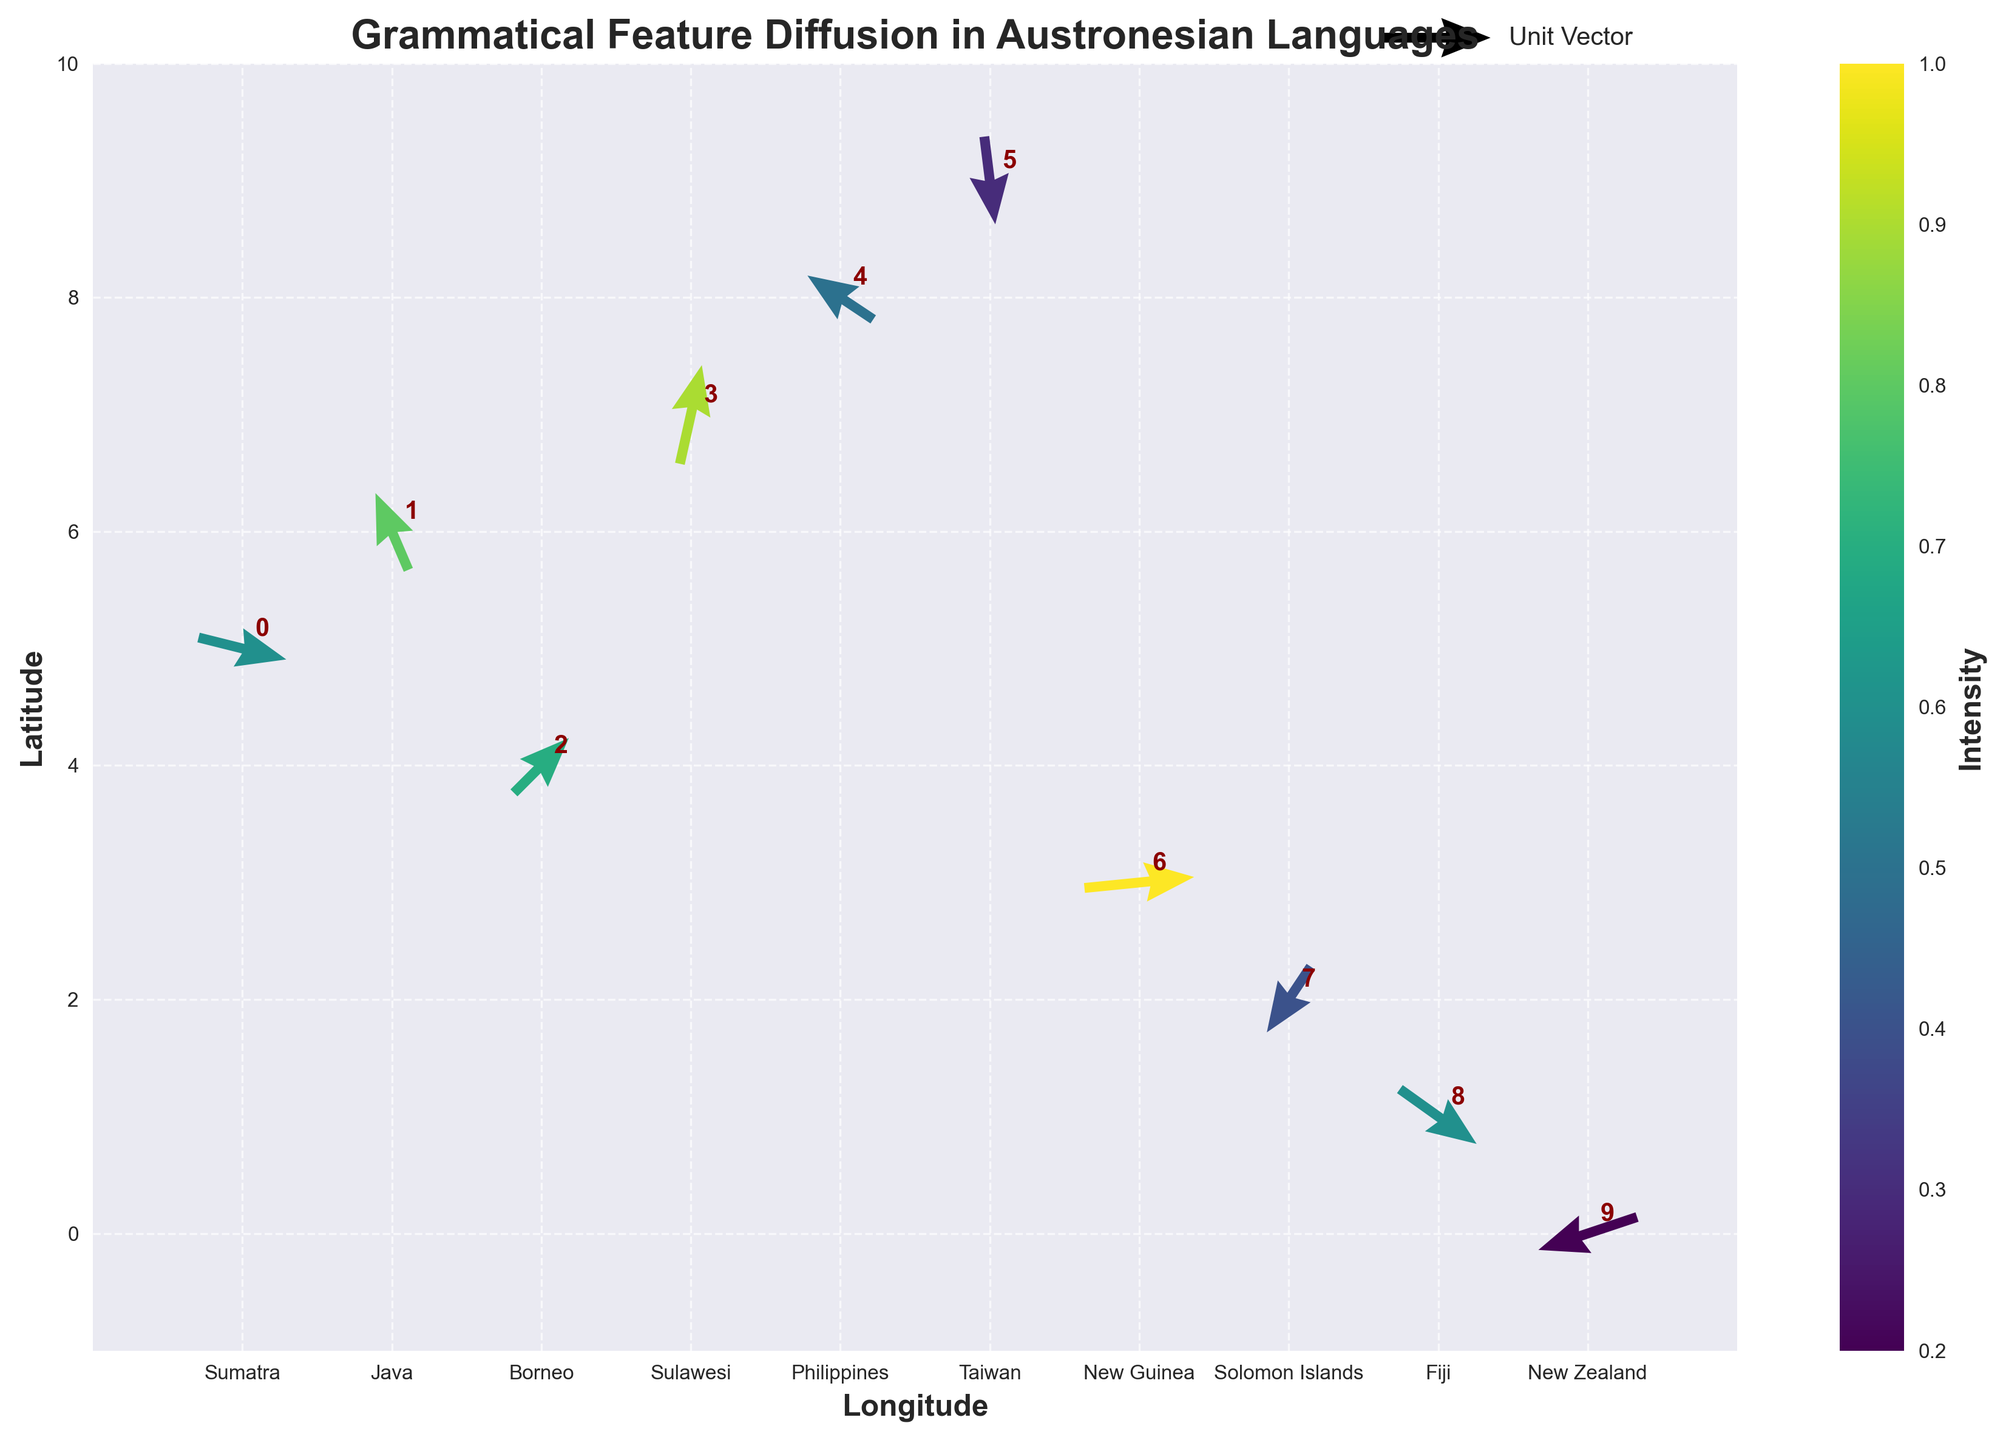What's the title of the plot? The title of the plot is often found at the top of the figure, clearly indicating the subject of the visualization. Here, the title "Grammatical Feature Diffusion in Austronesian Languages" is displayed at the top center.
Answer: Grammatical Feature Diffusion in Austronesian Languages Which islands have the highest and lowest intensities of grammatical feature diffusion? To find the highest and lowest intensities, look at the color bar and the arrows' colors. The highest intensity (brightest color) corresponds to New Guinea (intensity = 1.0), and the lowest intensity (dullest color) corresponds to New Zealand (intensity = 0.2).
Answer: New Guinea and New Zealand What is the direction and relative magnitude of grammatical feature diffusion in Java compared to New Guinea? Examine the direction and length of the arrows. In Java, the arrow points northwest (u = -0.3, v = 0.7) with moderate intensity. In New Guinea, the arrow points east (u = 1.0, v = 0.1) with the highest intensity. The arrow in New Guinea is longer, indicating a stronger magnitude.
Answer: Java: northwest, moderate; New Guinea: east, strong How do the intensities of grammatical feature diffusion in Borneo and the Solomon Islands compare? Use the color bar to compare the colors of the arrows. Borneo has an intensity of 0.7, indicated by a brighter green, while the Solomon Islands has an intensity of 0.4, indicated by a darker green. Therefore, Borneo's intensity is higher than the Solomon Islands'.
Answer: Borneo is higher Which two islands have vectors pointing in entirely opposite directions? Compare the vectors' directions for each island. The vectors for Taiwan (u = 0.1, v = -0.8) and Solomon Islands (u = -0.4, v = -0.6) point in generally opposite directions to each other.
Answer: Taiwan and Solomon Islands What is the average latitude (y-value) of the islands shown? Add the latitude values for all islands and divide by the number of islands: (5 + 6 + 4 + 7 + 8 + 9 + 3 + 2 + 1 + 0) / 10 = 4.5.
Answer: 4.5 Which island shows the greatest variance in vector direction compared to its neighboring island in longitude? Compare the direction (u, v) of vectors between neighboring islands. For example, Indonesia's Sulawesi (u = 0.2, v = 0.9) differs significantly in direction from the Philippines (u = -0.6, v = 0.4).
Answer: Sulawesi compared to the Philippines What is the average intensity of grammatical feature diffusion across all documented islands? Calculate the sum of intensity and divide by the number of islands: (0.6 + 0.8 + 0.7 + 0.9 + 0.5 + 0.3 + 1.0 + 0.4 + 0.6 + 0.2) / 10 = 0.6.
Answer: 0.6 